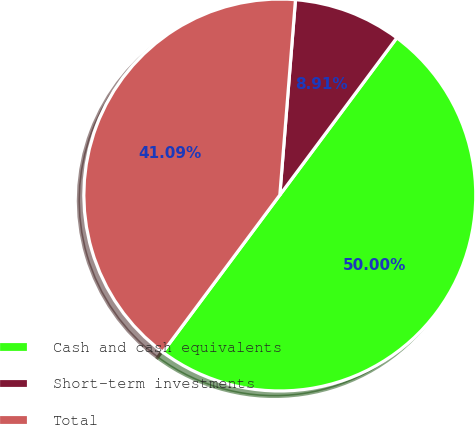<chart> <loc_0><loc_0><loc_500><loc_500><pie_chart><fcel>Cash and cash equivalents<fcel>Short-term investments<fcel>Total<nl><fcel>50.0%<fcel>8.91%<fcel>41.09%<nl></chart> 